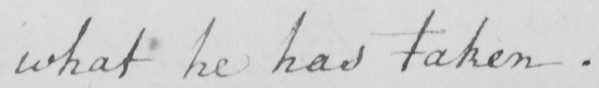Please provide the text content of this handwritten line. what he has taken . 